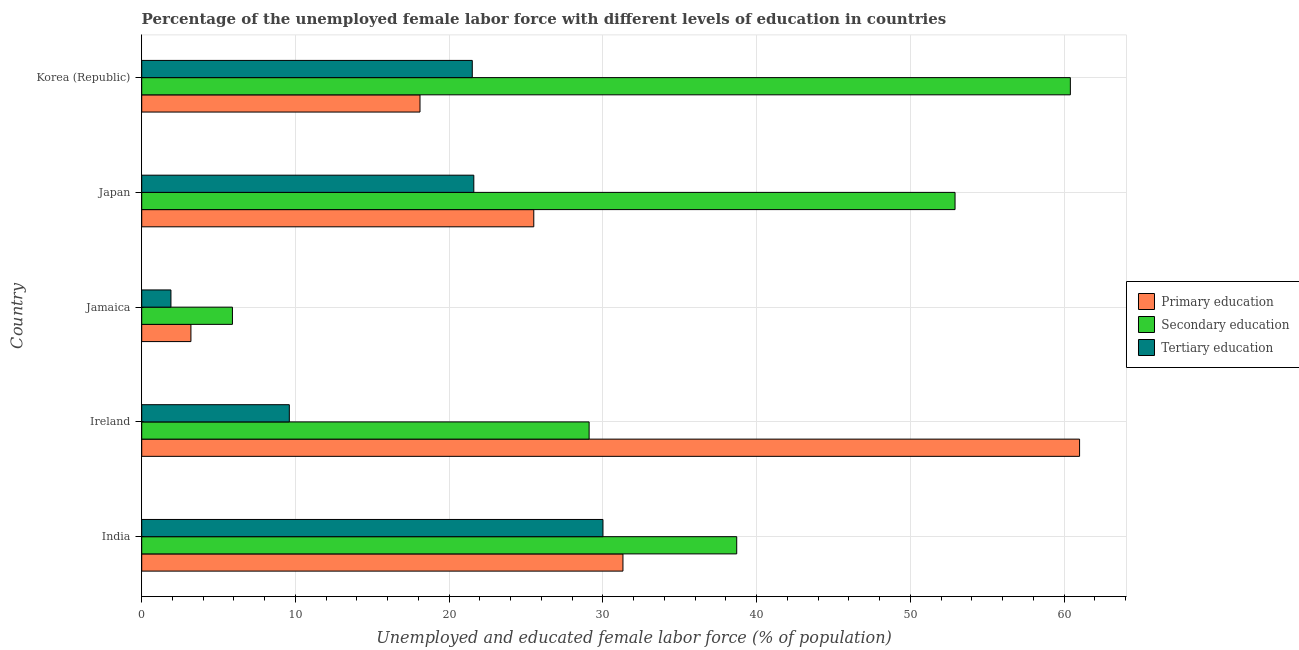Are the number of bars per tick equal to the number of legend labels?
Make the answer very short. Yes. Are the number of bars on each tick of the Y-axis equal?
Make the answer very short. Yes. What is the label of the 5th group of bars from the top?
Provide a short and direct response. India. Across all countries, what is the maximum percentage of female labor force who received secondary education?
Make the answer very short. 60.4. Across all countries, what is the minimum percentage of female labor force who received primary education?
Your answer should be compact. 3.2. In which country was the percentage of female labor force who received tertiary education maximum?
Make the answer very short. India. In which country was the percentage of female labor force who received tertiary education minimum?
Give a very brief answer. Jamaica. What is the total percentage of female labor force who received primary education in the graph?
Provide a succinct answer. 139.1. What is the difference between the percentage of female labor force who received primary education in India and that in Ireland?
Keep it short and to the point. -29.7. What is the difference between the percentage of female labor force who received primary education in Jamaica and the percentage of female labor force who received secondary education in Ireland?
Provide a succinct answer. -25.9. What is the average percentage of female labor force who received tertiary education per country?
Ensure brevity in your answer.  16.92. What is the difference between the percentage of female labor force who received primary education and percentage of female labor force who received tertiary education in Ireland?
Provide a succinct answer. 51.4. What is the ratio of the percentage of female labor force who received primary education in India to that in Ireland?
Offer a very short reply. 0.51. Is the difference between the percentage of female labor force who received primary education in India and Japan greater than the difference between the percentage of female labor force who received tertiary education in India and Japan?
Provide a short and direct response. No. What is the difference between the highest and the lowest percentage of female labor force who received primary education?
Your answer should be compact. 57.8. In how many countries, is the percentage of female labor force who received secondary education greater than the average percentage of female labor force who received secondary education taken over all countries?
Offer a terse response. 3. What does the 1st bar from the top in Ireland represents?
Give a very brief answer. Tertiary education. Is it the case that in every country, the sum of the percentage of female labor force who received primary education and percentage of female labor force who received secondary education is greater than the percentage of female labor force who received tertiary education?
Make the answer very short. Yes. How many countries are there in the graph?
Offer a terse response. 5. Are the values on the major ticks of X-axis written in scientific E-notation?
Give a very brief answer. No. Does the graph contain any zero values?
Provide a succinct answer. No. How many legend labels are there?
Make the answer very short. 3. What is the title of the graph?
Make the answer very short. Percentage of the unemployed female labor force with different levels of education in countries. What is the label or title of the X-axis?
Offer a very short reply. Unemployed and educated female labor force (% of population). What is the Unemployed and educated female labor force (% of population) of Primary education in India?
Keep it short and to the point. 31.3. What is the Unemployed and educated female labor force (% of population) in Secondary education in India?
Provide a short and direct response. 38.7. What is the Unemployed and educated female labor force (% of population) in Secondary education in Ireland?
Offer a terse response. 29.1. What is the Unemployed and educated female labor force (% of population) of Tertiary education in Ireland?
Offer a very short reply. 9.6. What is the Unemployed and educated female labor force (% of population) in Primary education in Jamaica?
Give a very brief answer. 3.2. What is the Unemployed and educated female labor force (% of population) of Secondary education in Jamaica?
Provide a short and direct response. 5.9. What is the Unemployed and educated female labor force (% of population) of Tertiary education in Jamaica?
Make the answer very short. 1.9. What is the Unemployed and educated female labor force (% of population) of Secondary education in Japan?
Offer a terse response. 52.9. What is the Unemployed and educated female labor force (% of population) of Tertiary education in Japan?
Ensure brevity in your answer.  21.6. What is the Unemployed and educated female labor force (% of population) of Primary education in Korea (Republic)?
Ensure brevity in your answer.  18.1. What is the Unemployed and educated female labor force (% of population) in Secondary education in Korea (Republic)?
Your answer should be compact. 60.4. Across all countries, what is the maximum Unemployed and educated female labor force (% of population) of Primary education?
Your response must be concise. 61. Across all countries, what is the maximum Unemployed and educated female labor force (% of population) in Secondary education?
Keep it short and to the point. 60.4. Across all countries, what is the minimum Unemployed and educated female labor force (% of population) in Primary education?
Your answer should be very brief. 3.2. Across all countries, what is the minimum Unemployed and educated female labor force (% of population) of Secondary education?
Give a very brief answer. 5.9. Across all countries, what is the minimum Unemployed and educated female labor force (% of population) of Tertiary education?
Your answer should be compact. 1.9. What is the total Unemployed and educated female labor force (% of population) in Primary education in the graph?
Offer a terse response. 139.1. What is the total Unemployed and educated female labor force (% of population) of Secondary education in the graph?
Give a very brief answer. 187. What is the total Unemployed and educated female labor force (% of population) of Tertiary education in the graph?
Make the answer very short. 84.6. What is the difference between the Unemployed and educated female labor force (% of population) in Primary education in India and that in Ireland?
Your response must be concise. -29.7. What is the difference between the Unemployed and educated female labor force (% of population) of Tertiary education in India and that in Ireland?
Keep it short and to the point. 20.4. What is the difference between the Unemployed and educated female labor force (% of population) in Primary education in India and that in Jamaica?
Provide a succinct answer. 28.1. What is the difference between the Unemployed and educated female labor force (% of population) in Secondary education in India and that in Jamaica?
Keep it short and to the point. 32.8. What is the difference between the Unemployed and educated female labor force (% of population) of Tertiary education in India and that in Jamaica?
Give a very brief answer. 28.1. What is the difference between the Unemployed and educated female labor force (% of population) of Secondary education in India and that in Korea (Republic)?
Your answer should be compact. -21.7. What is the difference between the Unemployed and educated female labor force (% of population) in Tertiary education in India and that in Korea (Republic)?
Keep it short and to the point. 8.5. What is the difference between the Unemployed and educated female labor force (% of population) in Primary education in Ireland and that in Jamaica?
Provide a succinct answer. 57.8. What is the difference between the Unemployed and educated female labor force (% of population) in Secondary education in Ireland and that in Jamaica?
Your response must be concise. 23.2. What is the difference between the Unemployed and educated female labor force (% of population) in Tertiary education in Ireland and that in Jamaica?
Offer a terse response. 7.7. What is the difference between the Unemployed and educated female labor force (% of population) of Primary education in Ireland and that in Japan?
Your response must be concise. 35.5. What is the difference between the Unemployed and educated female labor force (% of population) in Secondary education in Ireland and that in Japan?
Provide a succinct answer. -23.8. What is the difference between the Unemployed and educated female labor force (% of population) of Tertiary education in Ireland and that in Japan?
Your answer should be compact. -12. What is the difference between the Unemployed and educated female labor force (% of population) of Primary education in Ireland and that in Korea (Republic)?
Your response must be concise. 42.9. What is the difference between the Unemployed and educated female labor force (% of population) of Secondary education in Ireland and that in Korea (Republic)?
Provide a short and direct response. -31.3. What is the difference between the Unemployed and educated female labor force (% of population) of Tertiary education in Ireland and that in Korea (Republic)?
Make the answer very short. -11.9. What is the difference between the Unemployed and educated female labor force (% of population) in Primary education in Jamaica and that in Japan?
Make the answer very short. -22.3. What is the difference between the Unemployed and educated female labor force (% of population) of Secondary education in Jamaica and that in Japan?
Offer a terse response. -47. What is the difference between the Unemployed and educated female labor force (% of population) of Tertiary education in Jamaica and that in Japan?
Give a very brief answer. -19.7. What is the difference between the Unemployed and educated female labor force (% of population) in Primary education in Jamaica and that in Korea (Republic)?
Make the answer very short. -14.9. What is the difference between the Unemployed and educated female labor force (% of population) in Secondary education in Jamaica and that in Korea (Republic)?
Provide a short and direct response. -54.5. What is the difference between the Unemployed and educated female labor force (% of population) in Tertiary education in Jamaica and that in Korea (Republic)?
Offer a terse response. -19.6. What is the difference between the Unemployed and educated female labor force (% of population) in Primary education in Japan and that in Korea (Republic)?
Offer a terse response. 7.4. What is the difference between the Unemployed and educated female labor force (% of population) of Secondary education in Japan and that in Korea (Republic)?
Offer a terse response. -7.5. What is the difference between the Unemployed and educated female labor force (% of population) of Tertiary education in Japan and that in Korea (Republic)?
Ensure brevity in your answer.  0.1. What is the difference between the Unemployed and educated female labor force (% of population) of Primary education in India and the Unemployed and educated female labor force (% of population) of Secondary education in Ireland?
Your answer should be very brief. 2.2. What is the difference between the Unemployed and educated female labor force (% of population) in Primary education in India and the Unemployed and educated female labor force (% of population) in Tertiary education in Ireland?
Offer a terse response. 21.7. What is the difference between the Unemployed and educated female labor force (% of population) in Secondary education in India and the Unemployed and educated female labor force (% of population) in Tertiary education in Ireland?
Offer a terse response. 29.1. What is the difference between the Unemployed and educated female labor force (% of population) in Primary education in India and the Unemployed and educated female labor force (% of population) in Secondary education in Jamaica?
Keep it short and to the point. 25.4. What is the difference between the Unemployed and educated female labor force (% of population) of Primary education in India and the Unemployed and educated female labor force (% of population) of Tertiary education in Jamaica?
Your response must be concise. 29.4. What is the difference between the Unemployed and educated female labor force (% of population) of Secondary education in India and the Unemployed and educated female labor force (% of population) of Tertiary education in Jamaica?
Your answer should be very brief. 36.8. What is the difference between the Unemployed and educated female labor force (% of population) of Primary education in India and the Unemployed and educated female labor force (% of population) of Secondary education in Japan?
Your answer should be compact. -21.6. What is the difference between the Unemployed and educated female labor force (% of population) in Primary education in India and the Unemployed and educated female labor force (% of population) in Tertiary education in Japan?
Your response must be concise. 9.7. What is the difference between the Unemployed and educated female labor force (% of population) of Primary education in India and the Unemployed and educated female labor force (% of population) of Secondary education in Korea (Republic)?
Offer a terse response. -29.1. What is the difference between the Unemployed and educated female labor force (% of population) in Secondary education in India and the Unemployed and educated female labor force (% of population) in Tertiary education in Korea (Republic)?
Give a very brief answer. 17.2. What is the difference between the Unemployed and educated female labor force (% of population) in Primary education in Ireland and the Unemployed and educated female labor force (% of population) in Secondary education in Jamaica?
Provide a succinct answer. 55.1. What is the difference between the Unemployed and educated female labor force (% of population) in Primary education in Ireland and the Unemployed and educated female labor force (% of population) in Tertiary education in Jamaica?
Your answer should be compact. 59.1. What is the difference between the Unemployed and educated female labor force (% of population) in Secondary education in Ireland and the Unemployed and educated female labor force (% of population) in Tertiary education in Jamaica?
Provide a succinct answer. 27.2. What is the difference between the Unemployed and educated female labor force (% of population) of Primary education in Ireland and the Unemployed and educated female labor force (% of population) of Tertiary education in Japan?
Give a very brief answer. 39.4. What is the difference between the Unemployed and educated female labor force (% of population) of Primary education in Ireland and the Unemployed and educated female labor force (% of population) of Tertiary education in Korea (Republic)?
Provide a succinct answer. 39.5. What is the difference between the Unemployed and educated female labor force (% of population) of Secondary education in Ireland and the Unemployed and educated female labor force (% of population) of Tertiary education in Korea (Republic)?
Give a very brief answer. 7.6. What is the difference between the Unemployed and educated female labor force (% of population) in Primary education in Jamaica and the Unemployed and educated female labor force (% of population) in Secondary education in Japan?
Make the answer very short. -49.7. What is the difference between the Unemployed and educated female labor force (% of population) of Primary education in Jamaica and the Unemployed and educated female labor force (% of population) of Tertiary education in Japan?
Your answer should be compact. -18.4. What is the difference between the Unemployed and educated female labor force (% of population) of Secondary education in Jamaica and the Unemployed and educated female labor force (% of population) of Tertiary education in Japan?
Your response must be concise. -15.7. What is the difference between the Unemployed and educated female labor force (% of population) in Primary education in Jamaica and the Unemployed and educated female labor force (% of population) in Secondary education in Korea (Republic)?
Make the answer very short. -57.2. What is the difference between the Unemployed and educated female labor force (% of population) of Primary education in Jamaica and the Unemployed and educated female labor force (% of population) of Tertiary education in Korea (Republic)?
Offer a very short reply. -18.3. What is the difference between the Unemployed and educated female labor force (% of population) in Secondary education in Jamaica and the Unemployed and educated female labor force (% of population) in Tertiary education in Korea (Republic)?
Your response must be concise. -15.6. What is the difference between the Unemployed and educated female labor force (% of population) of Primary education in Japan and the Unemployed and educated female labor force (% of population) of Secondary education in Korea (Republic)?
Provide a succinct answer. -34.9. What is the difference between the Unemployed and educated female labor force (% of population) in Primary education in Japan and the Unemployed and educated female labor force (% of population) in Tertiary education in Korea (Republic)?
Your answer should be compact. 4. What is the difference between the Unemployed and educated female labor force (% of population) in Secondary education in Japan and the Unemployed and educated female labor force (% of population) in Tertiary education in Korea (Republic)?
Your response must be concise. 31.4. What is the average Unemployed and educated female labor force (% of population) in Primary education per country?
Provide a short and direct response. 27.82. What is the average Unemployed and educated female labor force (% of population) in Secondary education per country?
Provide a short and direct response. 37.4. What is the average Unemployed and educated female labor force (% of population) of Tertiary education per country?
Keep it short and to the point. 16.92. What is the difference between the Unemployed and educated female labor force (% of population) in Primary education and Unemployed and educated female labor force (% of population) in Secondary education in India?
Offer a terse response. -7.4. What is the difference between the Unemployed and educated female labor force (% of population) of Secondary education and Unemployed and educated female labor force (% of population) of Tertiary education in India?
Offer a very short reply. 8.7. What is the difference between the Unemployed and educated female labor force (% of population) in Primary education and Unemployed and educated female labor force (% of population) in Secondary education in Ireland?
Keep it short and to the point. 31.9. What is the difference between the Unemployed and educated female labor force (% of population) in Primary education and Unemployed and educated female labor force (% of population) in Tertiary education in Ireland?
Provide a short and direct response. 51.4. What is the difference between the Unemployed and educated female labor force (% of population) in Secondary education and Unemployed and educated female labor force (% of population) in Tertiary education in Ireland?
Your answer should be compact. 19.5. What is the difference between the Unemployed and educated female labor force (% of population) in Primary education and Unemployed and educated female labor force (% of population) in Secondary education in Jamaica?
Provide a short and direct response. -2.7. What is the difference between the Unemployed and educated female labor force (% of population) in Primary education and Unemployed and educated female labor force (% of population) in Tertiary education in Jamaica?
Your response must be concise. 1.3. What is the difference between the Unemployed and educated female labor force (% of population) of Primary education and Unemployed and educated female labor force (% of population) of Secondary education in Japan?
Offer a terse response. -27.4. What is the difference between the Unemployed and educated female labor force (% of population) of Secondary education and Unemployed and educated female labor force (% of population) of Tertiary education in Japan?
Provide a short and direct response. 31.3. What is the difference between the Unemployed and educated female labor force (% of population) of Primary education and Unemployed and educated female labor force (% of population) of Secondary education in Korea (Republic)?
Make the answer very short. -42.3. What is the difference between the Unemployed and educated female labor force (% of population) in Primary education and Unemployed and educated female labor force (% of population) in Tertiary education in Korea (Republic)?
Your response must be concise. -3.4. What is the difference between the Unemployed and educated female labor force (% of population) of Secondary education and Unemployed and educated female labor force (% of population) of Tertiary education in Korea (Republic)?
Offer a very short reply. 38.9. What is the ratio of the Unemployed and educated female labor force (% of population) of Primary education in India to that in Ireland?
Keep it short and to the point. 0.51. What is the ratio of the Unemployed and educated female labor force (% of population) in Secondary education in India to that in Ireland?
Ensure brevity in your answer.  1.33. What is the ratio of the Unemployed and educated female labor force (% of population) in Tertiary education in India to that in Ireland?
Provide a succinct answer. 3.12. What is the ratio of the Unemployed and educated female labor force (% of population) in Primary education in India to that in Jamaica?
Provide a short and direct response. 9.78. What is the ratio of the Unemployed and educated female labor force (% of population) in Secondary education in India to that in Jamaica?
Offer a very short reply. 6.56. What is the ratio of the Unemployed and educated female labor force (% of population) of Tertiary education in India to that in Jamaica?
Your answer should be very brief. 15.79. What is the ratio of the Unemployed and educated female labor force (% of population) of Primary education in India to that in Japan?
Keep it short and to the point. 1.23. What is the ratio of the Unemployed and educated female labor force (% of population) in Secondary education in India to that in Japan?
Offer a terse response. 0.73. What is the ratio of the Unemployed and educated female labor force (% of population) in Tertiary education in India to that in Japan?
Provide a short and direct response. 1.39. What is the ratio of the Unemployed and educated female labor force (% of population) in Primary education in India to that in Korea (Republic)?
Provide a succinct answer. 1.73. What is the ratio of the Unemployed and educated female labor force (% of population) in Secondary education in India to that in Korea (Republic)?
Your answer should be compact. 0.64. What is the ratio of the Unemployed and educated female labor force (% of population) in Tertiary education in India to that in Korea (Republic)?
Keep it short and to the point. 1.4. What is the ratio of the Unemployed and educated female labor force (% of population) in Primary education in Ireland to that in Jamaica?
Give a very brief answer. 19.06. What is the ratio of the Unemployed and educated female labor force (% of population) in Secondary education in Ireland to that in Jamaica?
Offer a terse response. 4.93. What is the ratio of the Unemployed and educated female labor force (% of population) of Tertiary education in Ireland to that in Jamaica?
Your answer should be very brief. 5.05. What is the ratio of the Unemployed and educated female labor force (% of population) of Primary education in Ireland to that in Japan?
Your answer should be very brief. 2.39. What is the ratio of the Unemployed and educated female labor force (% of population) in Secondary education in Ireland to that in Japan?
Offer a terse response. 0.55. What is the ratio of the Unemployed and educated female labor force (% of population) in Tertiary education in Ireland to that in Japan?
Ensure brevity in your answer.  0.44. What is the ratio of the Unemployed and educated female labor force (% of population) in Primary education in Ireland to that in Korea (Republic)?
Your answer should be very brief. 3.37. What is the ratio of the Unemployed and educated female labor force (% of population) in Secondary education in Ireland to that in Korea (Republic)?
Your response must be concise. 0.48. What is the ratio of the Unemployed and educated female labor force (% of population) of Tertiary education in Ireland to that in Korea (Republic)?
Your answer should be very brief. 0.45. What is the ratio of the Unemployed and educated female labor force (% of population) in Primary education in Jamaica to that in Japan?
Offer a terse response. 0.13. What is the ratio of the Unemployed and educated female labor force (% of population) of Secondary education in Jamaica to that in Japan?
Your response must be concise. 0.11. What is the ratio of the Unemployed and educated female labor force (% of population) of Tertiary education in Jamaica to that in Japan?
Offer a terse response. 0.09. What is the ratio of the Unemployed and educated female labor force (% of population) of Primary education in Jamaica to that in Korea (Republic)?
Your answer should be compact. 0.18. What is the ratio of the Unemployed and educated female labor force (% of population) in Secondary education in Jamaica to that in Korea (Republic)?
Your response must be concise. 0.1. What is the ratio of the Unemployed and educated female labor force (% of population) in Tertiary education in Jamaica to that in Korea (Republic)?
Offer a very short reply. 0.09. What is the ratio of the Unemployed and educated female labor force (% of population) in Primary education in Japan to that in Korea (Republic)?
Keep it short and to the point. 1.41. What is the ratio of the Unemployed and educated female labor force (% of population) of Secondary education in Japan to that in Korea (Republic)?
Your answer should be compact. 0.88. What is the difference between the highest and the second highest Unemployed and educated female labor force (% of population) in Primary education?
Ensure brevity in your answer.  29.7. What is the difference between the highest and the second highest Unemployed and educated female labor force (% of population) of Tertiary education?
Give a very brief answer. 8.4. What is the difference between the highest and the lowest Unemployed and educated female labor force (% of population) in Primary education?
Your answer should be compact. 57.8. What is the difference between the highest and the lowest Unemployed and educated female labor force (% of population) in Secondary education?
Ensure brevity in your answer.  54.5. What is the difference between the highest and the lowest Unemployed and educated female labor force (% of population) of Tertiary education?
Your answer should be compact. 28.1. 